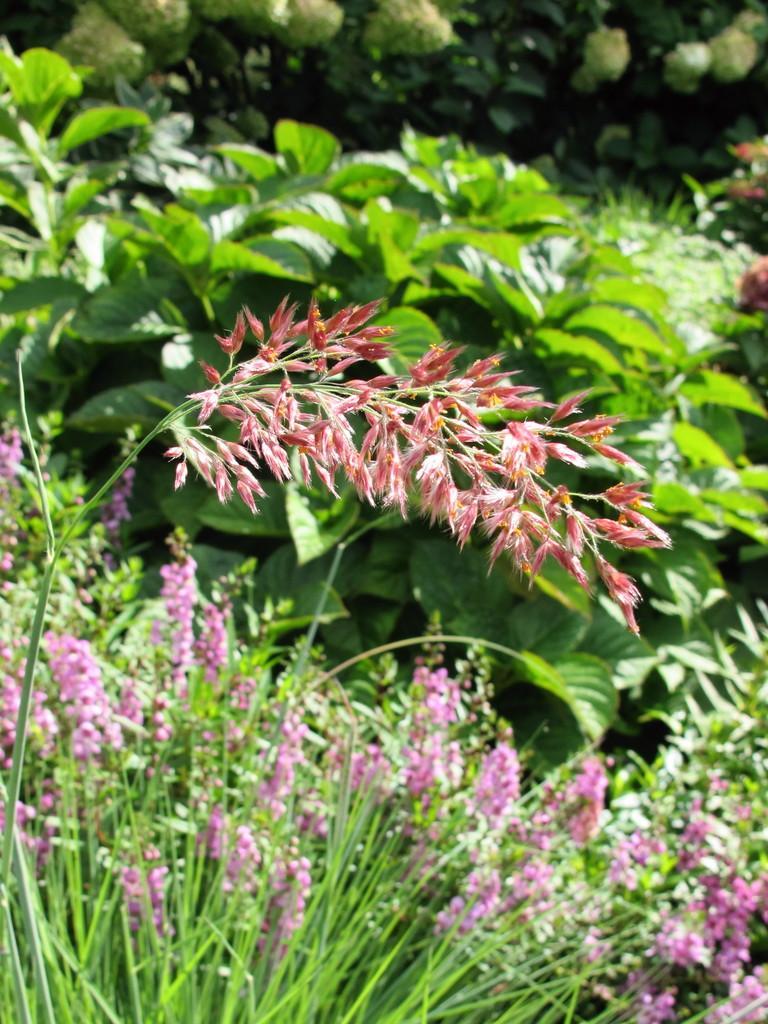Please provide a concise description of this image. In this picture we can observe some plants and flowers which were in pink and red color. In the background there are some trees. 